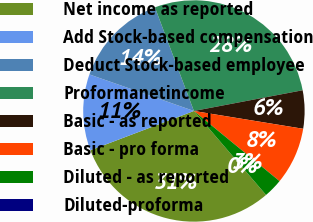<chart> <loc_0><loc_0><loc_500><loc_500><pie_chart><fcel>Net income as reported<fcel>Add Stock-based compensation<fcel>Deduct Stock-based employee<fcel>Proformanetincome<fcel>Basic - as reported<fcel>Basic - pro forma<fcel>Diluted - as reported<fcel>Diluted-proforma<nl><fcel>30.52%<fcel>11.13%<fcel>13.92%<fcel>27.73%<fcel>5.57%<fcel>8.35%<fcel>2.78%<fcel>0.0%<nl></chart> 